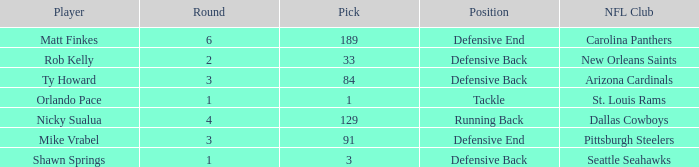What round has a pick less than 189, with arizona cardinals as the NFL club? 3.0. 